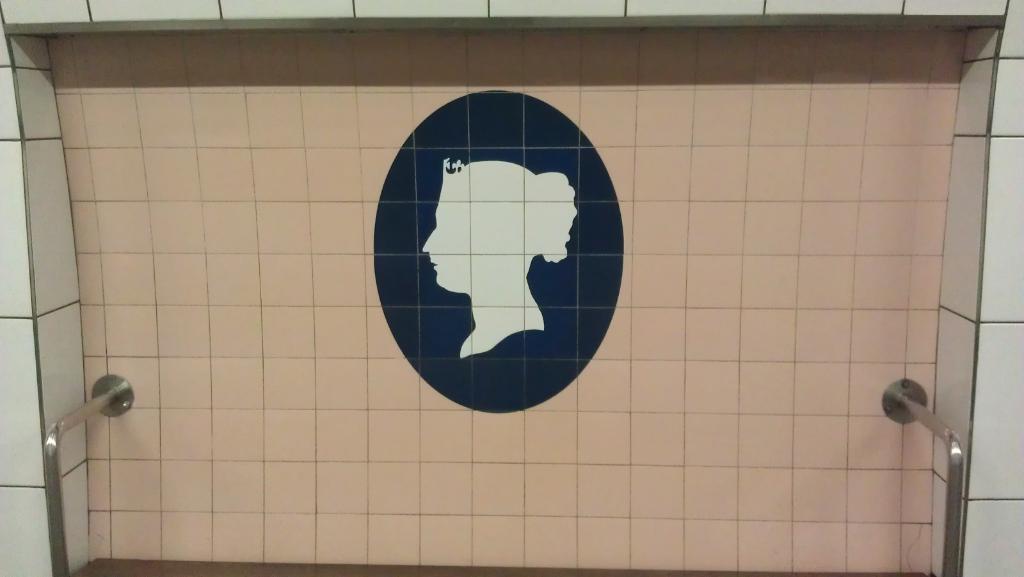How would you summarize this image in a sentence or two? In this image we can see the picture on a wall. We can also see some metal poles. 